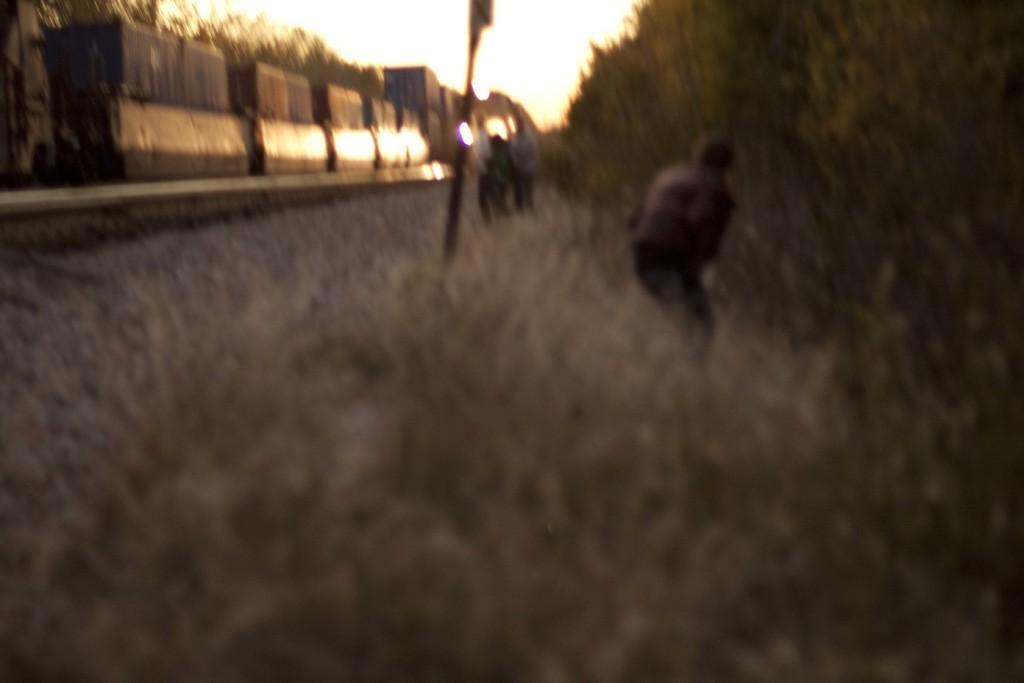In one or two sentences, can you explain what this image depicts? At the bottom we can see the grass. In the background there are few persons standing on the ground,pole,train on a railway track. On the left and right side we can see the trees and this is the sky. 